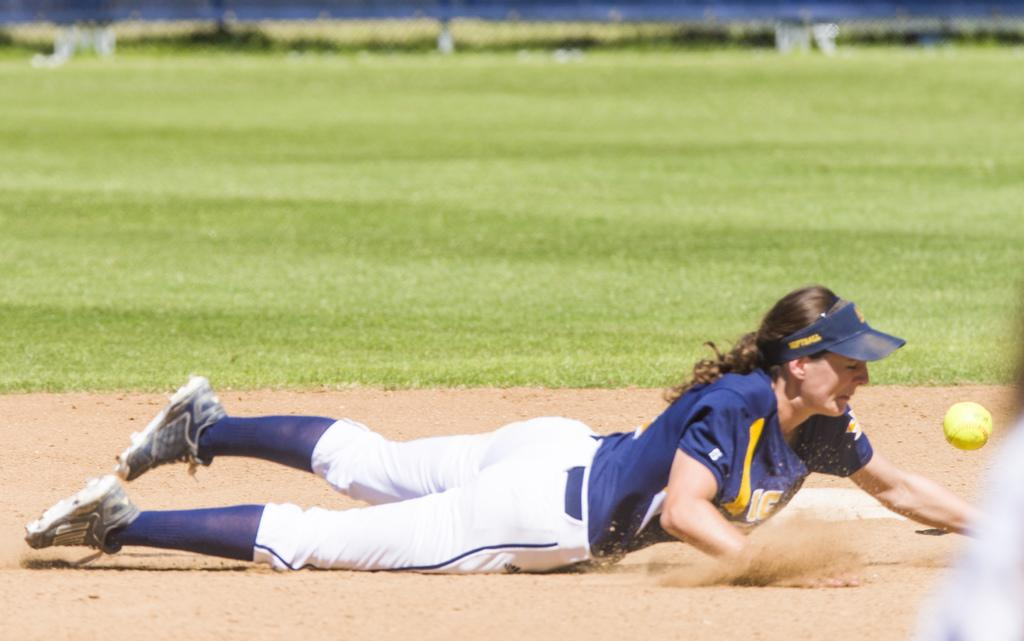What is the person in the image doing? The person is laying on the ground in the image. What object is present in the image besides the person? There is a ball in the image. What type of natural environment is visible in the background of the image? There is grass visible in the background of the image. What type of pig can be seen playing with a brick in the image? There is no pig or brick present in the image; it only features a person laying on the ground and a ball. 